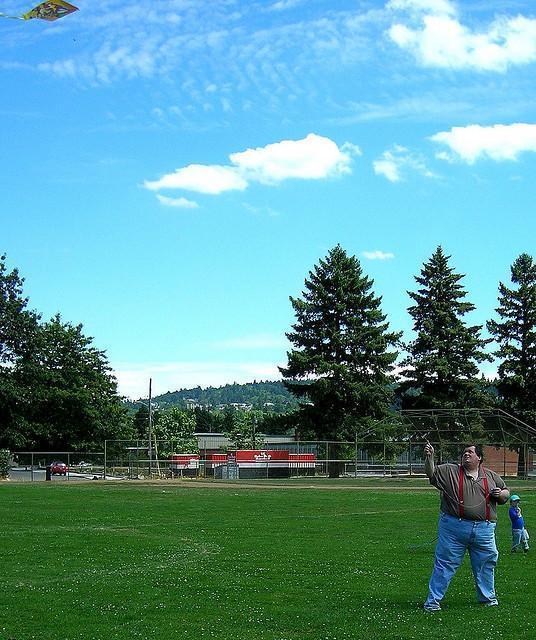The man in brown Controls what?
Select the correct answer and articulate reasoning with the following format: 'Answer: answer
Rationale: rationale.'
Options: Grass, kite, flowers, dog. Answer: kite.
Rationale: He is looking up at the kite and you can see a string in his hand. 